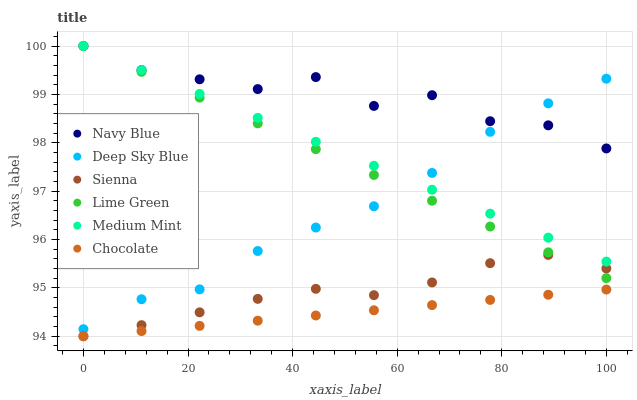Does Chocolate have the minimum area under the curve?
Answer yes or no. Yes. Does Navy Blue have the maximum area under the curve?
Answer yes or no. Yes. Does Navy Blue have the minimum area under the curve?
Answer yes or no. No. Does Chocolate have the maximum area under the curve?
Answer yes or no. No. Is Chocolate the smoothest?
Answer yes or no. Yes. Is Navy Blue the roughest?
Answer yes or no. Yes. Is Navy Blue the smoothest?
Answer yes or no. No. Is Chocolate the roughest?
Answer yes or no. No. Does Chocolate have the lowest value?
Answer yes or no. Yes. Does Navy Blue have the lowest value?
Answer yes or no. No. Does Lime Green have the highest value?
Answer yes or no. Yes. Does Chocolate have the highest value?
Answer yes or no. No. Is Sienna less than Navy Blue?
Answer yes or no. Yes. Is Medium Mint greater than Chocolate?
Answer yes or no. Yes. Does Lime Green intersect Navy Blue?
Answer yes or no. Yes. Is Lime Green less than Navy Blue?
Answer yes or no. No. Is Lime Green greater than Navy Blue?
Answer yes or no. No. Does Sienna intersect Navy Blue?
Answer yes or no. No. 